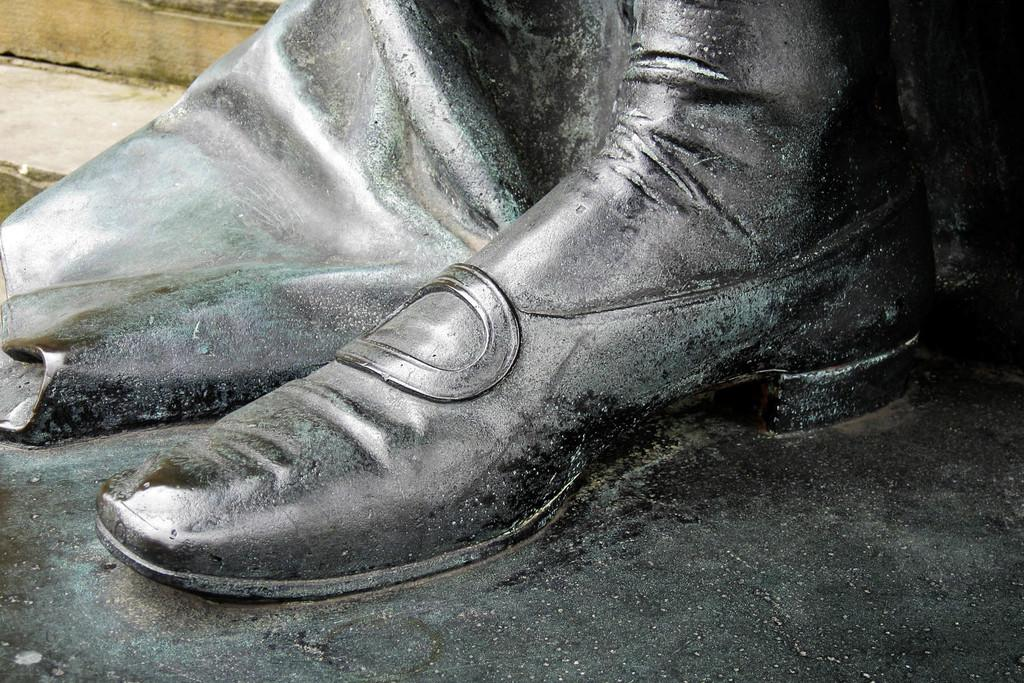What is the main subject of the image? The main subject of the image is a leg of a statue. Can you describe any other elements in the image? Yes, there are stairs in the top left corner of the image. Where is the throne located in the image? There is no throne present in the image. Is there a river flowing through the image? There is no river visible in the image. 